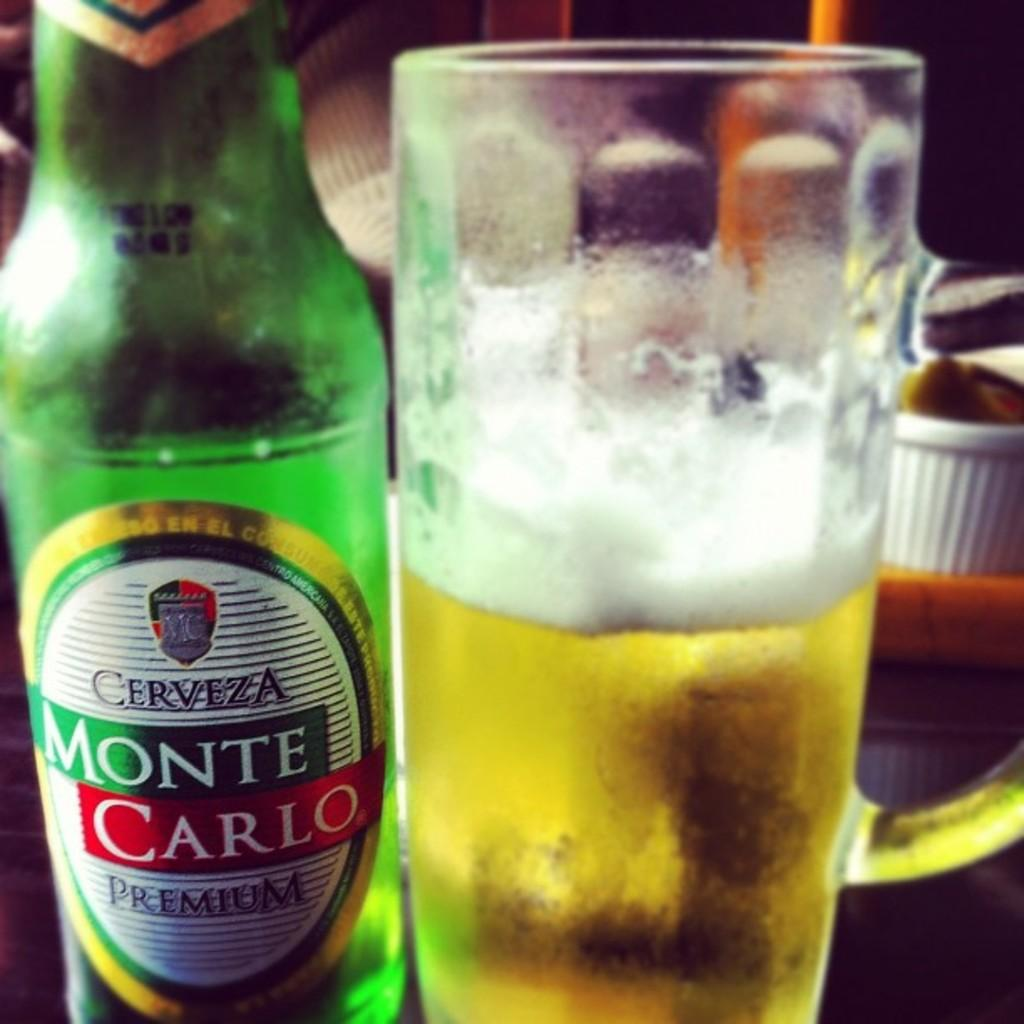<image>
Share a concise interpretation of the image provided. A bottle of Monte Carlo Cerveza sits next a glass 